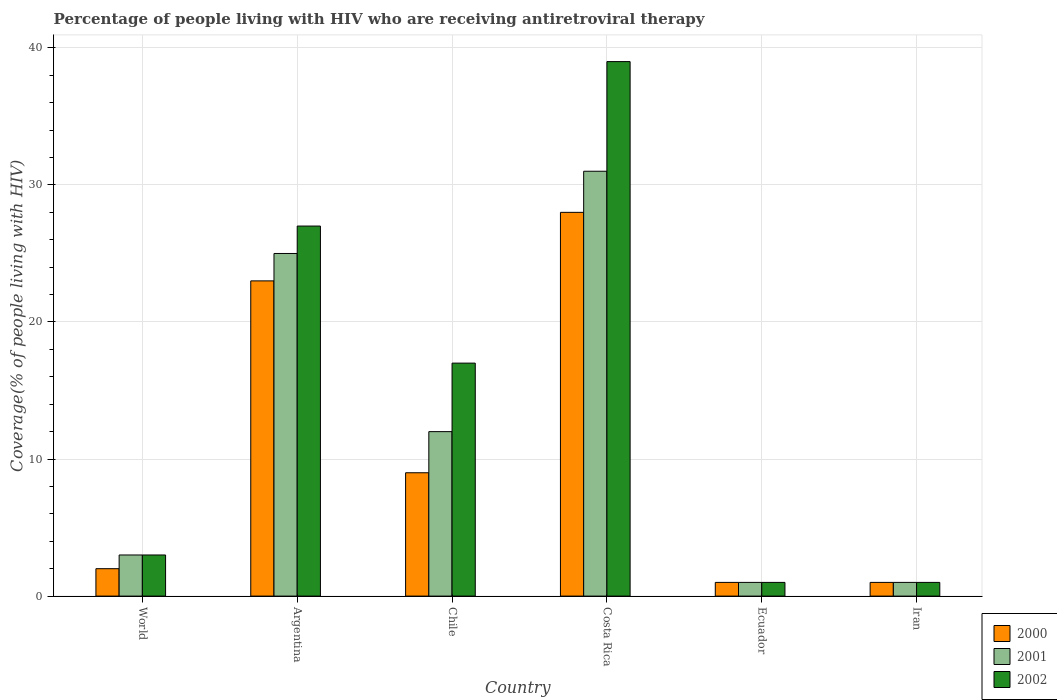How many different coloured bars are there?
Give a very brief answer. 3. How many groups of bars are there?
Offer a very short reply. 6. How many bars are there on the 2nd tick from the left?
Your answer should be compact. 3. What is the label of the 5th group of bars from the left?
Make the answer very short. Ecuador. What is the percentage of the HIV infected people who are receiving antiretroviral therapy in 2002 in Chile?
Provide a short and direct response. 17. In which country was the percentage of the HIV infected people who are receiving antiretroviral therapy in 2000 maximum?
Offer a very short reply. Costa Rica. In which country was the percentage of the HIV infected people who are receiving antiretroviral therapy in 2001 minimum?
Provide a short and direct response. Ecuador. What is the average percentage of the HIV infected people who are receiving antiretroviral therapy in 2000 per country?
Your answer should be compact. 10.67. What is the ratio of the percentage of the HIV infected people who are receiving antiretroviral therapy in 2001 in Argentina to that in Costa Rica?
Your answer should be compact. 0.81. Is the percentage of the HIV infected people who are receiving antiretroviral therapy in 2000 in Costa Rica less than that in Iran?
Give a very brief answer. No. Is the difference between the percentage of the HIV infected people who are receiving antiretroviral therapy in 2000 in Chile and Costa Rica greater than the difference between the percentage of the HIV infected people who are receiving antiretroviral therapy in 2001 in Chile and Costa Rica?
Provide a short and direct response. No. What is the difference between the highest and the second highest percentage of the HIV infected people who are receiving antiretroviral therapy in 2001?
Keep it short and to the point. 13. Is the sum of the percentage of the HIV infected people who are receiving antiretroviral therapy in 2000 in Ecuador and World greater than the maximum percentage of the HIV infected people who are receiving antiretroviral therapy in 2001 across all countries?
Offer a terse response. No. What does the 1st bar from the right in Argentina represents?
Keep it short and to the point. 2002. What is the difference between two consecutive major ticks on the Y-axis?
Offer a terse response. 10. Does the graph contain grids?
Keep it short and to the point. Yes. Where does the legend appear in the graph?
Offer a very short reply. Bottom right. How are the legend labels stacked?
Your answer should be compact. Vertical. What is the title of the graph?
Your answer should be compact. Percentage of people living with HIV who are receiving antiretroviral therapy. What is the label or title of the Y-axis?
Your answer should be very brief. Coverage(% of people living with HIV). What is the Coverage(% of people living with HIV) in 2000 in World?
Your answer should be compact. 2. What is the Coverage(% of people living with HIV) of 2001 in World?
Give a very brief answer. 3. What is the Coverage(% of people living with HIV) in 2002 in Argentina?
Offer a terse response. 27. What is the Coverage(% of people living with HIV) in 2002 in Chile?
Your response must be concise. 17. What is the Coverage(% of people living with HIV) in 2000 in Costa Rica?
Give a very brief answer. 28. What is the Coverage(% of people living with HIV) in 2001 in Costa Rica?
Offer a very short reply. 31. What is the Coverage(% of people living with HIV) in 2000 in Ecuador?
Your answer should be very brief. 1. What is the Coverage(% of people living with HIV) in 2000 in Iran?
Make the answer very short. 1. What is the Coverage(% of people living with HIV) in 2002 in Iran?
Keep it short and to the point. 1. Across all countries, what is the maximum Coverage(% of people living with HIV) in 2001?
Your answer should be compact. 31. Across all countries, what is the maximum Coverage(% of people living with HIV) of 2002?
Make the answer very short. 39. Across all countries, what is the minimum Coverage(% of people living with HIV) in 2001?
Your answer should be very brief. 1. What is the total Coverage(% of people living with HIV) in 2000 in the graph?
Your response must be concise. 64. What is the total Coverage(% of people living with HIV) in 2002 in the graph?
Your answer should be compact. 88. What is the difference between the Coverage(% of people living with HIV) in 2002 in World and that in Argentina?
Offer a terse response. -24. What is the difference between the Coverage(% of people living with HIV) of 2000 in World and that in Chile?
Your answer should be very brief. -7. What is the difference between the Coverage(% of people living with HIV) of 2001 in World and that in Chile?
Your answer should be very brief. -9. What is the difference between the Coverage(% of people living with HIV) of 2002 in World and that in Chile?
Your answer should be compact. -14. What is the difference between the Coverage(% of people living with HIV) of 2000 in World and that in Costa Rica?
Give a very brief answer. -26. What is the difference between the Coverage(% of people living with HIV) of 2002 in World and that in Costa Rica?
Provide a short and direct response. -36. What is the difference between the Coverage(% of people living with HIV) of 2001 in World and that in Ecuador?
Ensure brevity in your answer.  2. What is the difference between the Coverage(% of people living with HIV) in 2002 in World and that in Ecuador?
Make the answer very short. 2. What is the difference between the Coverage(% of people living with HIV) in 2001 in World and that in Iran?
Offer a very short reply. 2. What is the difference between the Coverage(% of people living with HIV) of 2002 in World and that in Iran?
Ensure brevity in your answer.  2. What is the difference between the Coverage(% of people living with HIV) of 2000 in Argentina and that in Chile?
Offer a very short reply. 14. What is the difference between the Coverage(% of people living with HIV) in 2002 in Argentina and that in Chile?
Your answer should be very brief. 10. What is the difference between the Coverage(% of people living with HIV) of 2000 in Argentina and that in Costa Rica?
Your response must be concise. -5. What is the difference between the Coverage(% of people living with HIV) in 2001 in Argentina and that in Ecuador?
Your answer should be compact. 24. What is the difference between the Coverage(% of people living with HIV) in 2000 in Argentina and that in Iran?
Offer a very short reply. 22. What is the difference between the Coverage(% of people living with HIV) of 2002 in Chile and that in Costa Rica?
Give a very brief answer. -22. What is the difference between the Coverage(% of people living with HIV) of 2000 in Chile and that in Ecuador?
Your answer should be compact. 8. What is the difference between the Coverage(% of people living with HIV) in 2001 in Chile and that in Ecuador?
Make the answer very short. 11. What is the difference between the Coverage(% of people living with HIV) of 2002 in Chile and that in Ecuador?
Keep it short and to the point. 16. What is the difference between the Coverage(% of people living with HIV) of 2002 in Chile and that in Iran?
Your answer should be very brief. 16. What is the difference between the Coverage(% of people living with HIV) of 2001 in Costa Rica and that in Ecuador?
Ensure brevity in your answer.  30. What is the difference between the Coverage(% of people living with HIV) in 2002 in Costa Rica and that in Ecuador?
Offer a very short reply. 38. What is the difference between the Coverage(% of people living with HIV) in 2000 in Costa Rica and that in Iran?
Ensure brevity in your answer.  27. What is the difference between the Coverage(% of people living with HIV) of 2002 in Costa Rica and that in Iran?
Provide a succinct answer. 38. What is the difference between the Coverage(% of people living with HIV) in 2000 in Ecuador and that in Iran?
Give a very brief answer. 0. What is the difference between the Coverage(% of people living with HIV) in 2001 in Ecuador and that in Iran?
Give a very brief answer. 0. What is the difference between the Coverage(% of people living with HIV) in 2002 in Ecuador and that in Iran?
Offer a very short reply. 0. What is the difference between the Coverage(% of people living with HIV) in 2001 in World and the Coverage(% of people living with HIV) in 2002 in Argentina?
Keep it short and to the point. -24. What is the difference between the Coverage(% of people living with HIV) in 2001 in World and the Coverage(% of people living with HIV) in 2002 in Chile?
Offer a very short reply. -14. What is the difference between the Coverage(% of people living with HIV) of 2000 in World and the Coverage(% of people living with HIV) of 2001 in Costa Rica?
Give a very brief answer. -29. What is the difference between the Coverage(% of people living with HIV) of 2000 in World and the Coverage(% of people living with HIV) of 2002 in Costa Rica?
Provide a succinct answer. -37. What is the difference between the Coverage(% of people living with HIV) in 2001 in World and the Coverage(% of people living with HIV) in 2002 in Costa Rica?
Provide a succinct answer. -36. What is the difference between the Coverage(% of people living with HIV) in 2000 in World and the Coverage(% of people living with HIV) in 2002 in Ecuador?
Give a very brief answer. 1. What is the difference between the Coverage(% of people living with HIV) in 2000 in World and the Coverage(% of people living with HIV) in 2002 in Iran?
Provide a succinct answer. 1. What is the difference between the Coverage(% of people living with HIV) of 2001 in World and the Coverage(% of people living with HIV) of 2002 in Iran?
Make the answer very short. 2. What is the difference between the Coverage(% of people living with HIV) in 2000 in Argentina and the Coverage(% of people living with HIV) in 2001 in Chile?
Give a very brief answer. 11. What is the difference between the Coverage(% of people living with HIV) of 2000 in Argentina and the Coverage(% of people living with HIV) of 2002 in Chile?
Your answer should be very brief. 6. What is the difference between the Coverage(% of people living with HIV) in 2001 in Argentina and the Coverage(% of people living with HIV) in 2002 in Chile?
Give a very brief answer. 8. What is the difference between the Coverage(% of people living with HIV) of 2000 in Argentina and the Coverage(% of people living with HIV) of 2002 in Costa Rica?
Your response must be concise. -16. What is the difference between the Coverage(% of people living with HIV) of 2000 in Argentina and the Coverage(% of people living with HIV) of 2002 in Ecuador?
Provide a short and direct response. 22. What is the difference between the Coverage(% of people living with HIV) in 2000 in Argentina and the Coverage(% of people living with HIV) in 2001 in Iran?
Give a very brief answer. 22. What is the difference between the Coverage(% of people living with HIV) in 2000 in Argentina and the Coverage(% of people living with HIV) in 2002 in Iran?
Provide a short and direct response. 22. What is the difference between the Coverage(% of people living with HIV) of 2000 in Chile and the Coverage(% of people living with HIV) of 2001 in Costa Rica?
Make the answer very short. -22. What is the difference between the Coverage(% of people living with HIV) of 2000 in Chile and the Coverage(% of people living with HIV) of 2002 in Costa Rica?
Provide a succinct answer. -30. What is the difference between the Coverage(% of people living with HIV) in 2001 in Chile and the Coverage(% of people living with HIV) in 2002 in Costa Rica?
Offer a terse response. -27. What is the difference between the Coverage(% of people living with HIV) in 2001 in Chile and the Coverage(% of people living with HIV) in 2002 in Iran?
Provide a short and direct response. 11. What is the difference between the Coverage(% of people living with HIV) in 2000 in Costa Rica and the Coverage(% of people living with HIV) in 2001 in Ecuador?
Keep it short and to the point. 27. What is the difference between the Coverage(% of people living with HIV) in 2000 in Costa Rica and the Coverage(% of people living with HIV) in 2002 in Ecuador?
Provide a succinct answer. 27. What is the difference between the Coverage(% of people living with HIV) of 2000 in Costa Rica and the Coverage(% of people living with HIV) of 2001 in Iran?
Your answer should be compact. 27. What is the difference between the Coverage(% of people living with HIV) in 2001 in Costa Rica and the Coverage(% of people living with HIV) in 2002 in Iran?
Keep it short and to the point. 30. What is the difference between the Coverage(% of people living with HIV) in 2000 in Ecuador and the Coverage(% of people living with HIV) in 2001 in Iran?
Your answer should be very brief. 0. What is the difference between the Coverage(% of people living with HIV) of 2001 in Ecuador and the Coverage(% of people living with HIV) of 2002 in Iran?
Give a very brief answer. 0. What is the average Coverage(% of people living with HIV) in 2000 per country?
Offer a terse response. 10.67. What is the average Coverage(% of people living with HIV) in 2001 per country?
Your answer should be compact. 12.17. What is the average Coverage(% of people living with HIV) in 2002 per country?
Provide a short and direct response. 14.67. What is the difference between the Coverage(% of people living with HIV) of 2000 and Coverage(% of people living with HIV) of 2001 in World?
Make the answer very short. -1. What is the difference between the Coverage(% of people living with HIV) of 2001 and Coverage(% of people living with HIV) of 2002 in World?
Ensure brevity in your answer.  0. What is the difference between the Coverage(% of people living with HIV) of 2000 and Coverage(% of people living with HIV) of 2001 in Argentina?
Offer a very short reply. -2. What is the difference between the Coverage(% of people living with HIV) in 2000 and Coverage(% of people living with HIV) in 2002 in Argentina?
Offer a terse response. -4. What is the difference between the Coverage(% of people living with HIV) in 2000 and Coverage(% of people living with HIV) in 2002 in Chile?
Your answer should be very brief. -8. What is the difference between the Coverage(% of people living with HIV) of 2000 and Coverage(% of people living with HIV) of 2002 in Costa Rica?
Give a very brief answer. -11. What is the difference between the Coverage(% of people living with HIV) of 2000 and Coverage(% of people living with HIV) of 2001 in Ecuador?
Offer a very short reply. 0. What is the difference between the Coverage(% of people living with HIV) of 2000 and Coverage(% of people living with HIV) of 2002 in Iran?
Give a very brief answer. 0. What is the ratio of the Coverage(% of people living with HIV) in 2000 in World to that in Argentina?
Ensure brevity in your answer.  0.09. What is the ratio of the Coverage(% of people living with HIV) in 2001 in World to that in Argentina?
Give a very brief answer. 0.12. What is the ratio of the Coverage(% of people living with HIV) of 2002 in World to that in Argentina?
Make the answer very short. 0.11. What is the ratio of the Coverage(% of people living with HIV) in 2000 in World to that in Chile?
Provide a short and direct response. 0.22. What is the ratio of the Coverage(% of people living with HIV) of 2001 in World to that in Chile?
Offer a terse response. 0.25. What is the ratio of the Coverage(% of people living with HIV) in 2002 in World to that in Chile?
Provide a succinct answer. 0.18. What is the ratio of the Coverage(% of people living with HIV) of 2000 in World to that in Costa Rica?
Your answer should be very brief. 0.07. What is the ratio of the Coverage(% of people living with HIV) of 2001 in World to that in Costa Rica?
Make the answer very short. 0.1. What is the ratio of the Coverage(% of people living with HIV) in 2002 in World to that in Costa Rica?
Offer a very short reply. 0.08. What is the ratio of the Coverage(% of people living with HIV) in 2000 in World to that in Ecuador?
Provide a short and direct response. 2. What is the ratio of the Coverage(% of people living with HIV) of 2000 in World to that in Iran?
Your answer should be compact. 2. What is the ratio of the Coverage(% of people living with HIV) of 2001 in World to that in Iran?
Give a very brief answer. 3. What is the ratio of the Coverage(% of people living with HIV) of 2002 in World to that in Iran?
Offer a very short reply. 3. What is the ratio of the Coverage(% of people living with HIV) of 2000 in Argentina to that in Chile?
Provide a succinct answer. 2.56. What is the ratio of the Coverage(% of people living with HIV) in 2001 in Argentina to that in Chile?
Your answer should be very brief. 2.08. What is the ratio of the Coverage(% of people living with HIV) in 2002 in Argentina to that in Chile?
Provide a succinct answer. 1.59. What is the ratio of the Coverage(% of people living with HIV) in 2000 in Argentina to that in Costa Rica?
Keep it short and to the point. 0.82. What is the ratio of the Coverage(% of people living with HIV) in 2001 in Argentina to that in Costa Rica?
Your response must be concise. 0.81. What is the ratio of the Coverage(% of people living with HIV) of 2002 in Argentina to that in Costa Rica?
Offer a very short reply. 0.69. What is the ratio of the Coverage(% of people living with HIV) in 2001 in Argentina to that in Iran?
Provide a short and direct response. 25. What is the ratio of the Coverage(% of people living with HIV) in 2002 in Argentina to that in Iran?
Ensure brevity in your answer.  27. What is the ratio of the Coverage(% of people living with HIV) in 2000 in Chile to that in Costa Rica?
Your response must be concise. 0.32. What is the ratio of the Coverage(% of people living with HIV) in 2001 in Chile to that in Costa Rica?
Your response must be concise. 0.39. What is the ratio of the Coverage(% of people living with HIV) of 2002 in Chile to that in Costa Rica?
Offer a very short reply. 0.44. What is the ratio of the Coverage(% of people living with HIV) in 2002 in Chile to that in Ecuador?
Provide a short and direct response. 17. What is the ratio of the Coverage(% of people living with HIV) of 2001 in Chile to that in Iran?
Provide a succinct answer. 12. What is the ratio of the Coverage(% of people living with HIV) in 2002 in Chile to that in Iran?
Make the answer very short. 17. What is the ratio of the Coverage(% of people living with HIV) in 2002 in Costa Rica to that in Iran?
Ensure brevity in your answer.  39. What is the ratio of the Coverage(% of people living with HIV) of 2001 in Ecuador to that in Iran?
Your answer should be compact. 1. What is the difference between the highest and the second highest Coverage(% of people living with HIV) of 2000?
Offer a terse response. 5. What is the difference between the highest and the second highest Coverage(% of people living with HIV) of 2001?
Give a very brief answer. 6. What is the difference between the highest and the second highest Coverage(% of people living with HIV) in 2002?
Give a very brief answer. 12. What is the difference between the highest and the lowest Coverage(% of people living with HIV) of 2000?
Offer a terse response. 27. 